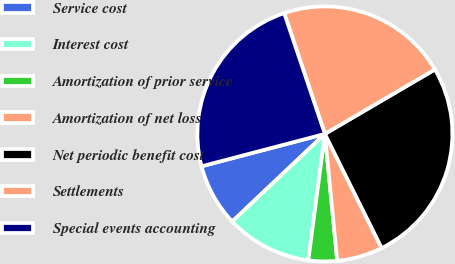Convert chart. <chart><loc_0><loc_0><loc_500><loc_500><pie_chart><fcel>Service cost<fcel>Interest cost<fcel>Amortization of prior service<fcel>Amortization of net loss<fcel>Net periodic benefit cost<fcel>Settlements<fcel>Special events accounting<nl><fcel>7.97%<fcel>10.87%<fcel>3.62%<fcel>5.8%<fcel>26.09%<fcel>21.74%<fcel>23.91%<nl></chart> 